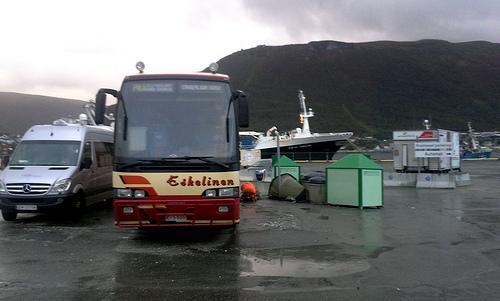How many vehicles are in this picture?
Give a very brief answer. 2. 